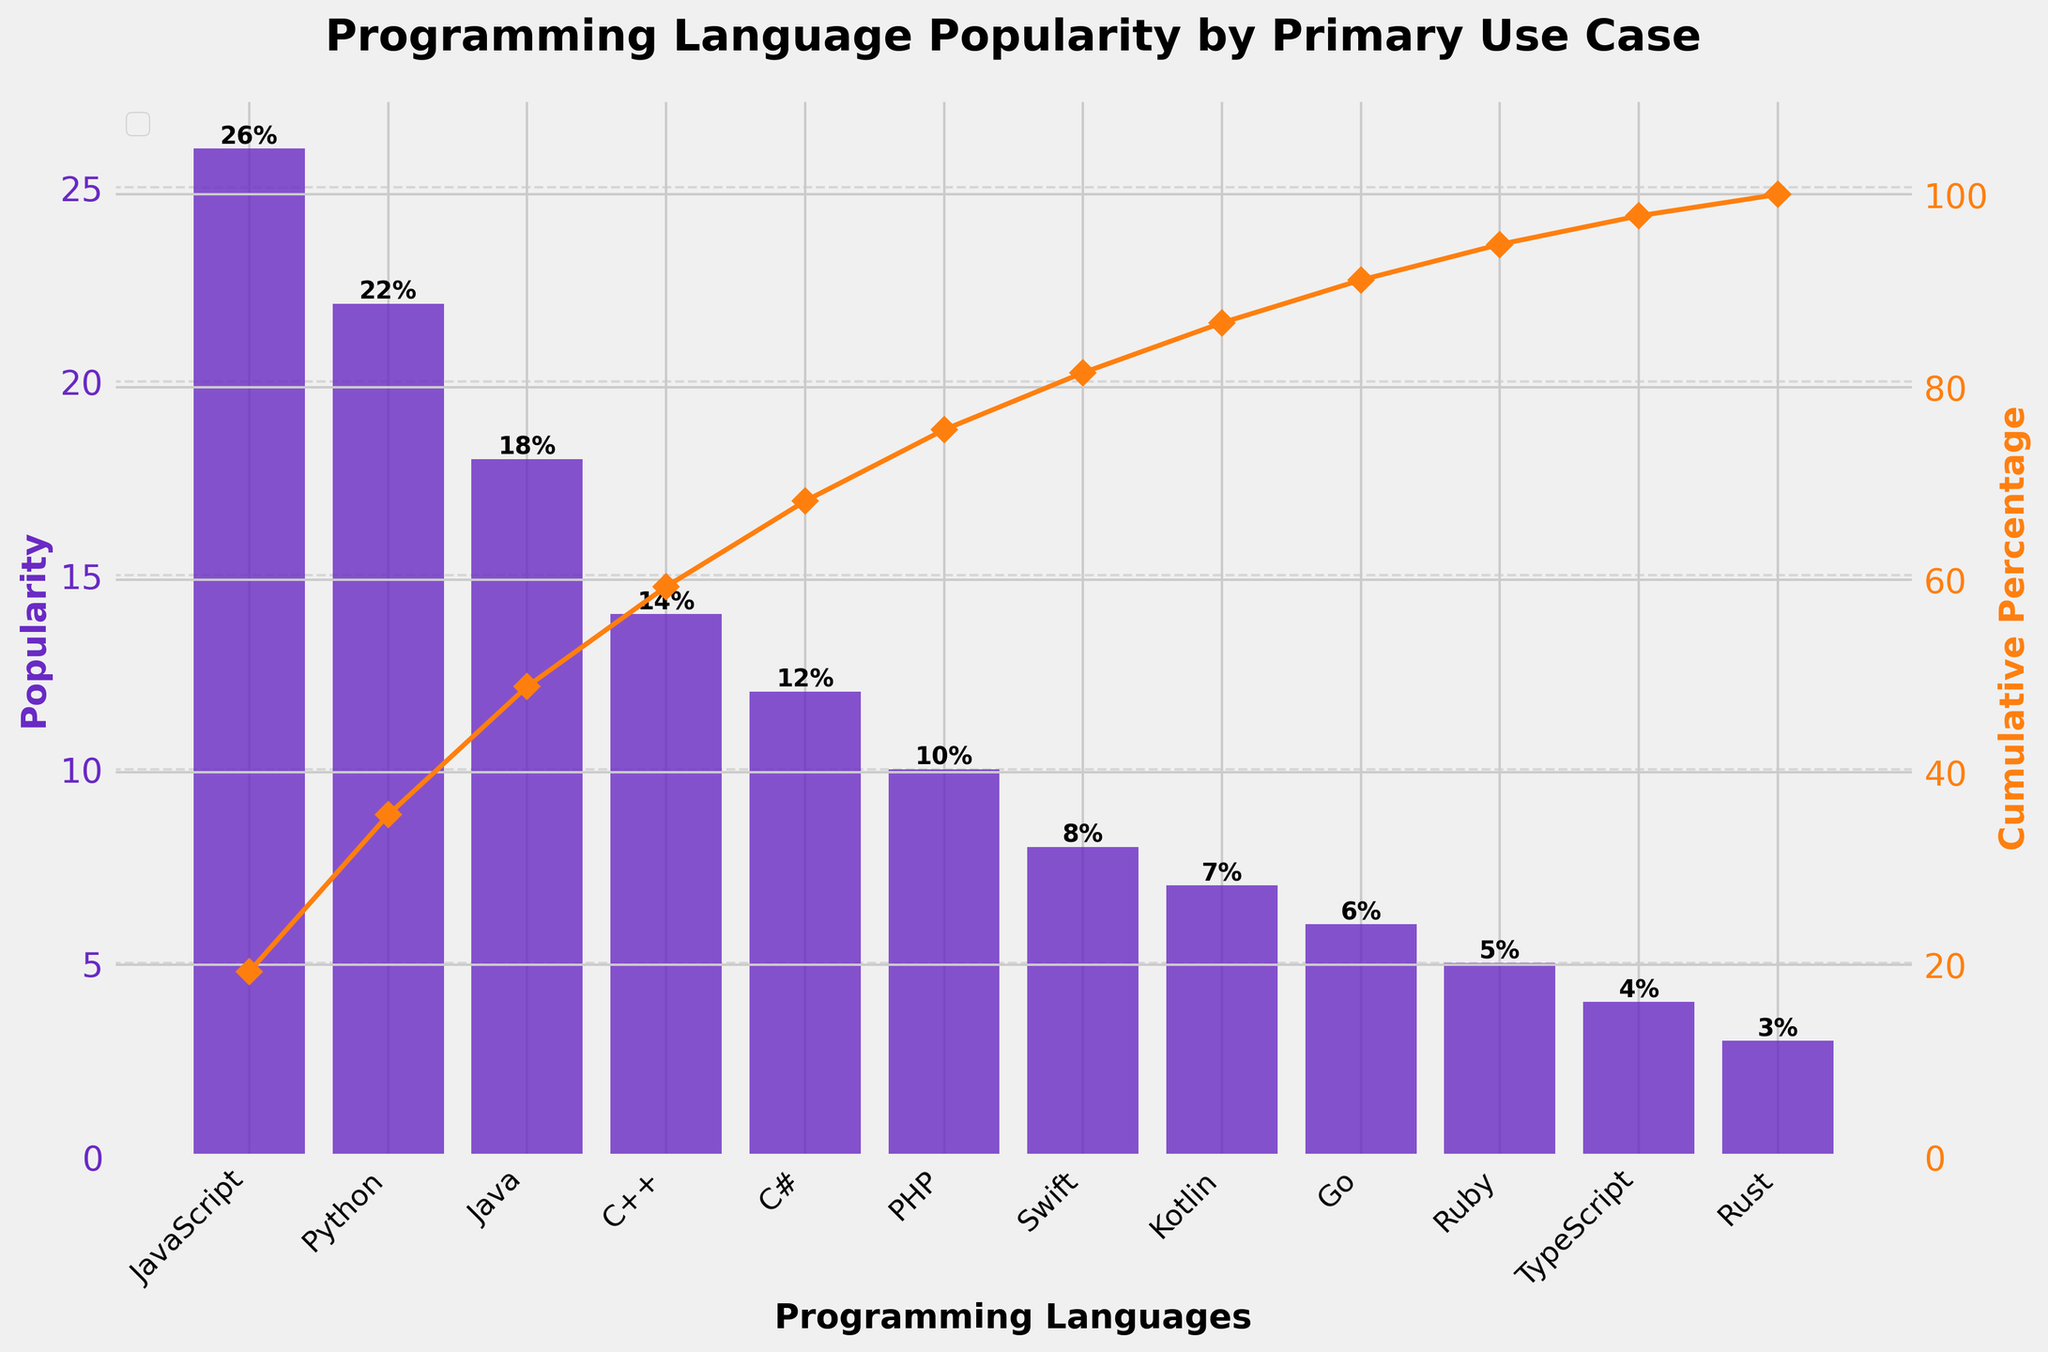How many programming languages are represented in the chart? Count the number of bars in the chart to identify the number of unique programming languages.
Answer: 12 What is the primary use case for Python according to the chart? Look at the x-axis to find Python and read its associated primary use case from the provided data.
Answer: Data Science Which programming language has the lowest popularity? Find the bar with the shortest height and check its label on the x-axis.
Answer: Rust What is the cumulative percentage when you reach C++ in the chart? Trace the cumulative percentage line up to the point where it meets the bar for C++ and read the percentage from the right y-axis.
Answer: 80% What's the sum of the popularity percentages for JavaScript and Python? Add the popularity percentages of JavaScript (26%) and Python (22%) from the height of their respective bars. 26 + 22 = 48
Answer: 48 Which two languages combined make up just above 50% of the cumulative percentage? Look at the cumulative percentage line and find the last two languages before the cumulative percentage exceeds 50%.
Answer: JavaScript and Python How many languages have a primary use case in web-related development? Identify languages with primary use cases related to web development: JavaScript (Web Development), PHP (Web Backend), Ruby (Web Frameworks), and TypeScript (Large-scale JavaScript). Count these languages.
Answer: 4 What is the difference in popularity between Java and Go? Subtract the popularity percentage of Go (6%) from that of Java (18%). 18 - 6 = 12
Answer: 12 Which language's popularity brings the cumulative percentage closest to 75%? Check the cumulative percentage line and find the language that brings the total closest to 75% when added.
Answer: Java What is the color used for the popularity bars in the chart? Observe the color of the bars representing popularity data on the chart.
Answer: Purple 